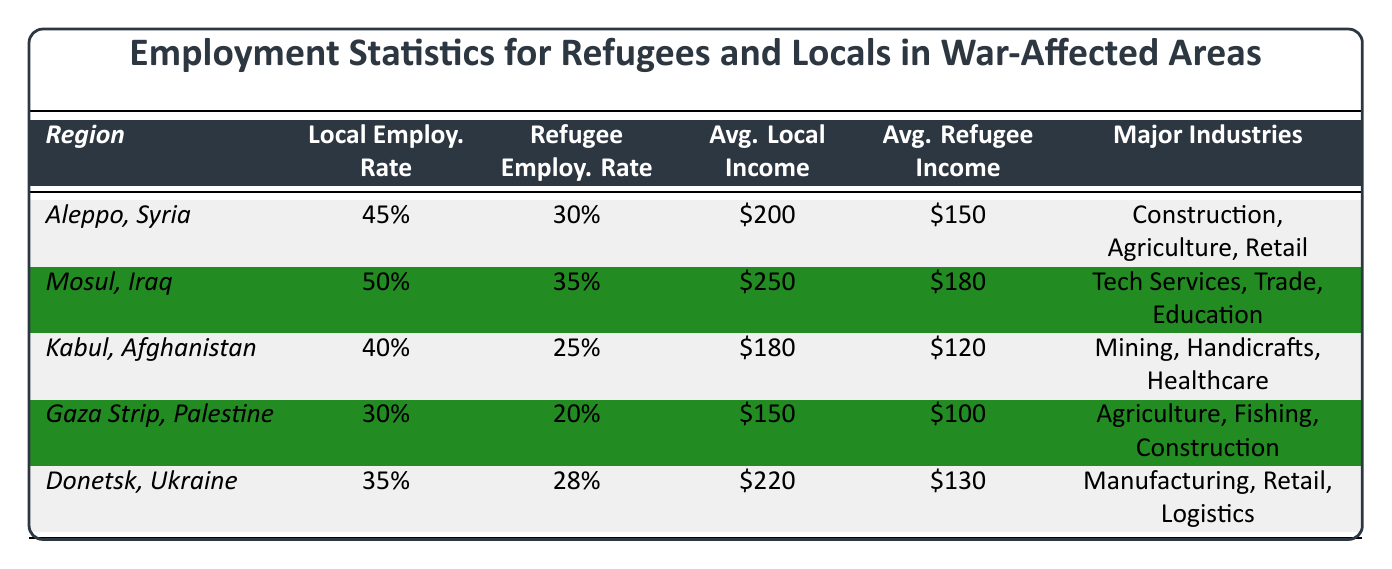What is the local employment rate in Aleppo, Syria? The table shows that the local employment rate in Aleppo, Syria, is listed as 45%.
Answer: 45% What is the average monthly income for refugees in Mosul, Iraq? According to the table, the average monthly income for refugees in Mosul is $180.
Answer: $180 Which region has the highest local employment rate? By comparing the local employment rates, Mosul, Iraq, has the highest rate at 50%.
Answer: Mosul, Iraq What is the difference in average monthly income between locals and refugees in Kabul, Afghanistan? The average monthly income for locals in Kabul is $180 and for refugees, it is $120. The difference is $180 - $120 = $60.
Answer: $60 True or False: The refugee employment rate is higher in the Gaza Strip than in Donetsk, Ukraine. The table shows the refugee employment rate in Gaza Strip is 20% and in Donetsk, Ukraine, it is 28%. Since 20% is lower than 28%, the statement is false.
Answer: False What is the average employment rate of locals across all regions? To find the average local employment rate, we sum the rates: 45% + 50% + 40% + 30% + 35% = 200%, then divide by the number of regions (5) which gives us 200% / 5 = 40%.
Answer: 40% Which major industry is common to both Aleppo, Syria, and Gaza Strip, Palestine? By looking at the major industries listed for each region, "Construction" is mentioned in both Aleppo and Gaza Strip.
Answer: Construction If we combine the refugee employment rates from Mosul, Iraq, and Donetsk, Ukraine, what do we get? The refugee employment rate in Mosul is 35% and in Donetsk, it is 28%. When we add them: 35% + 28% = 63%.
Answer: 63% How does the average monthly income for refugees in the Gaza Strip compare to the average monthly income for locals in Kabul? The average monthly income for refugees in Gaza Strip is $100, and for locals in Kabul, it is $180. $100 is less than $180.
Answer: Less What region has the lowest refugee employment rate? By comparing the refugee employment rates, Gaza Strip has the lowest rate at 20%.
Answer: Gaza Strip 